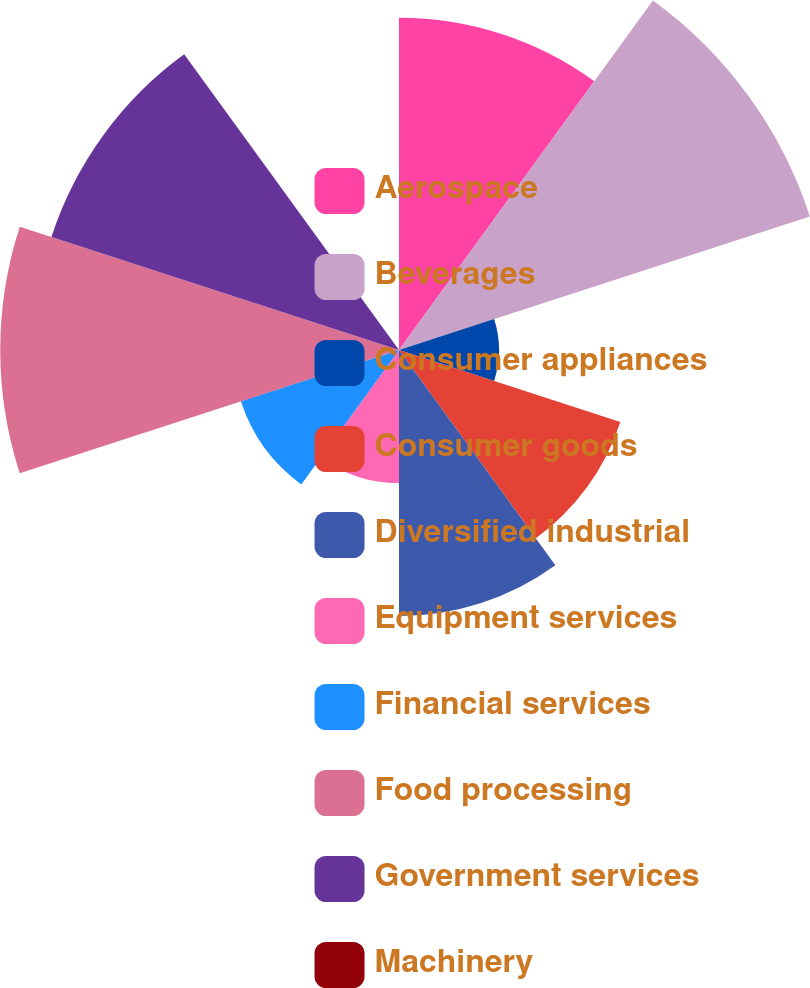Convert chart. <chart><loc_0><loc_0><loc_500><loc_500><pie_chart><fcel>Aerospace<fcel>Beverages<fcel>Consumer appliances<fcel>Consumer goods<fcel>Diversified industrial<fcel>Equipment services<fcel>Financial services<fcel>Food processing<fcel>Government services<fcel>Machinery<nl><fcel>13.69%<fcel>17.8%<fcel>4.12%<fcel>9.59%<fcel>10.96%<fcel>5.49%<fcel>6.85%<fcel>16.43%<fcel>15.06%<fcel>0.01%<nl></chart> 